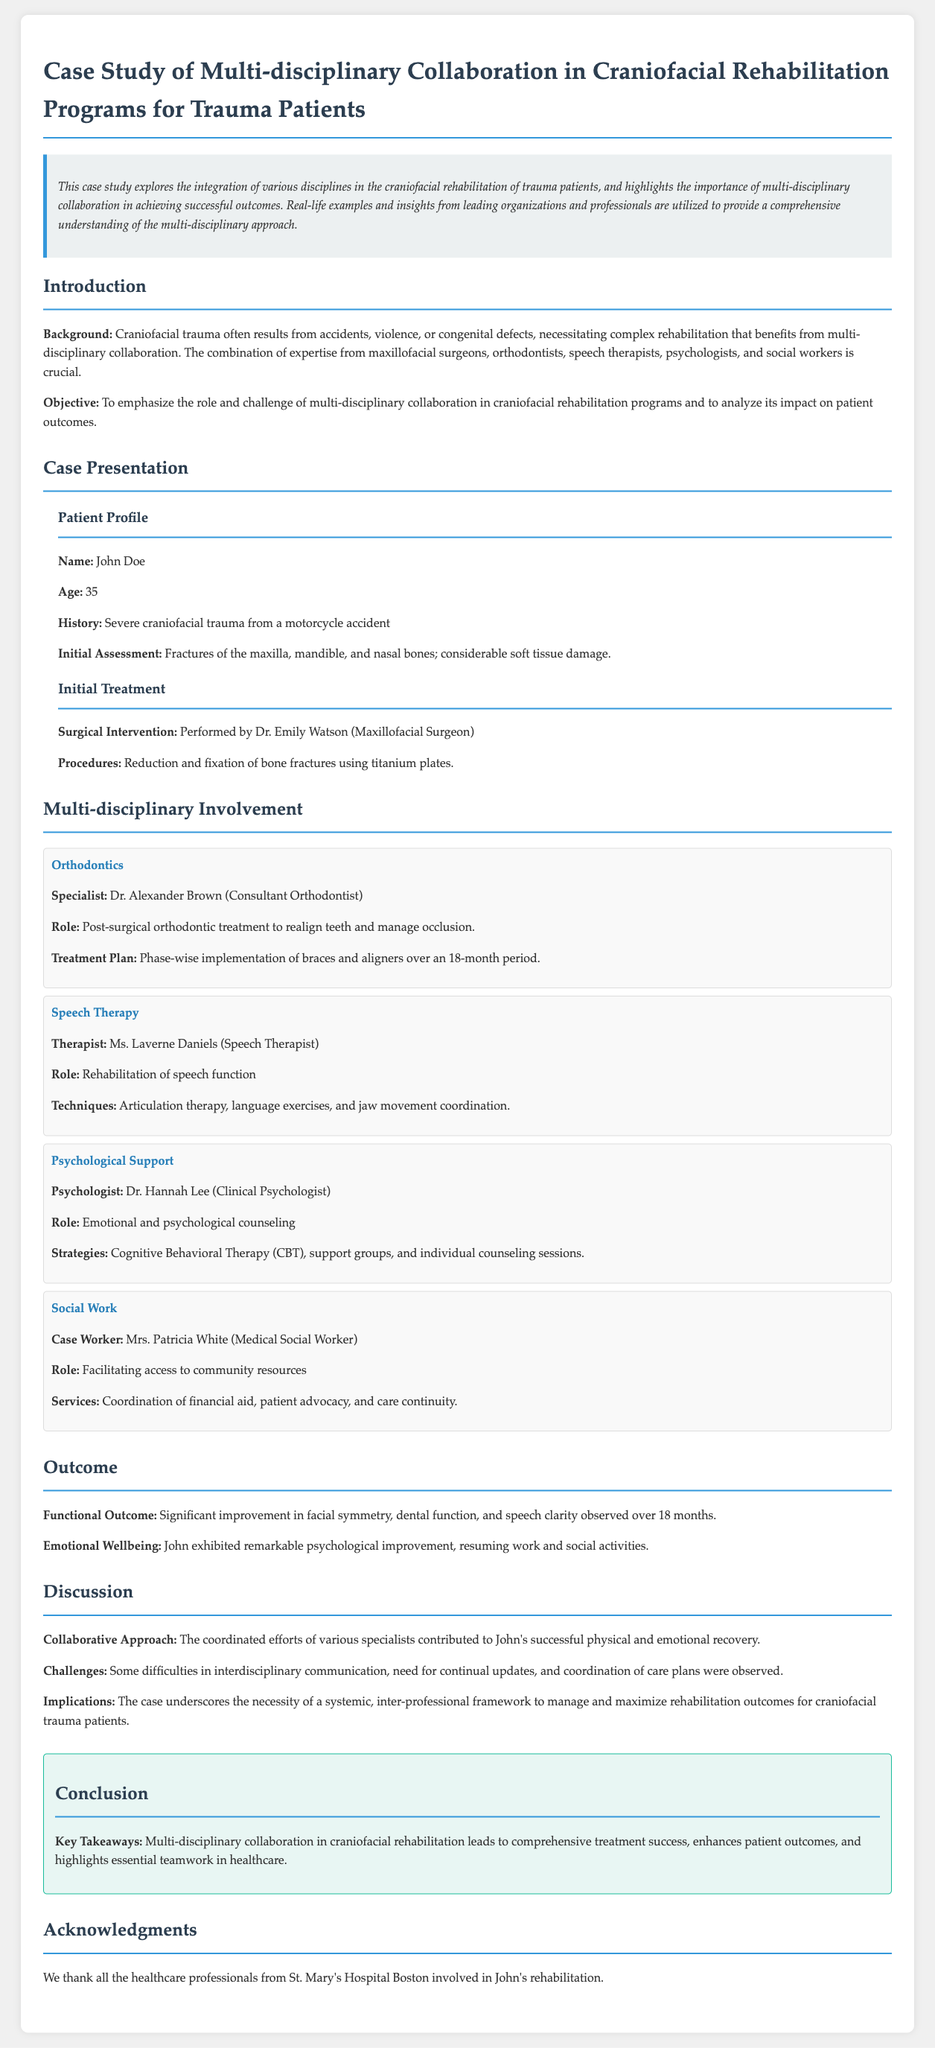What is the name of the patient in this case study? The name of the patient is mentioned in the case presentation section.
Answer: John Doe Who performed the surgical intervention? The document specifies the name and role of the surgeon involved in the initial treatment.
Answer: Dr. Emily Watson What was the age of the patient at the time of the accident? The patient’s age is provided in the patient profile section.
Answer: 35 What type of therapy was conducted by Ms. Laverne Daniels? The document explains the role of the speech therapist, including the type of therapy provided.
Answer: Speech therapy What was the duration of the orthodontic treatment plan? The treatment plan duration is outlined in the multi-disciplinary involvement section.
Answer: 18 months Which type of psychological therapy was used in the case? The psychologist's strategies are detailed, indicating the type of therapy applied.
Answer: Cognitive Behavioral Therapy What improvement was observed in John after treatment? The outcome section describes improvements noted after the rehabilitation process.
Answer: Significant improvement in facial symmetry What is highlighted as a challenge in the multi-disciplinary approach? The discussion section points out some of the challenges faced during the rehabilitation process.
Answer: Interdisciplinary communication What conclusion is drawn about multi-disciplinary collaboration? The conclusion summarizes key takeaways from the study regarding collaboration.
Answer: Enhances patient outcomes 